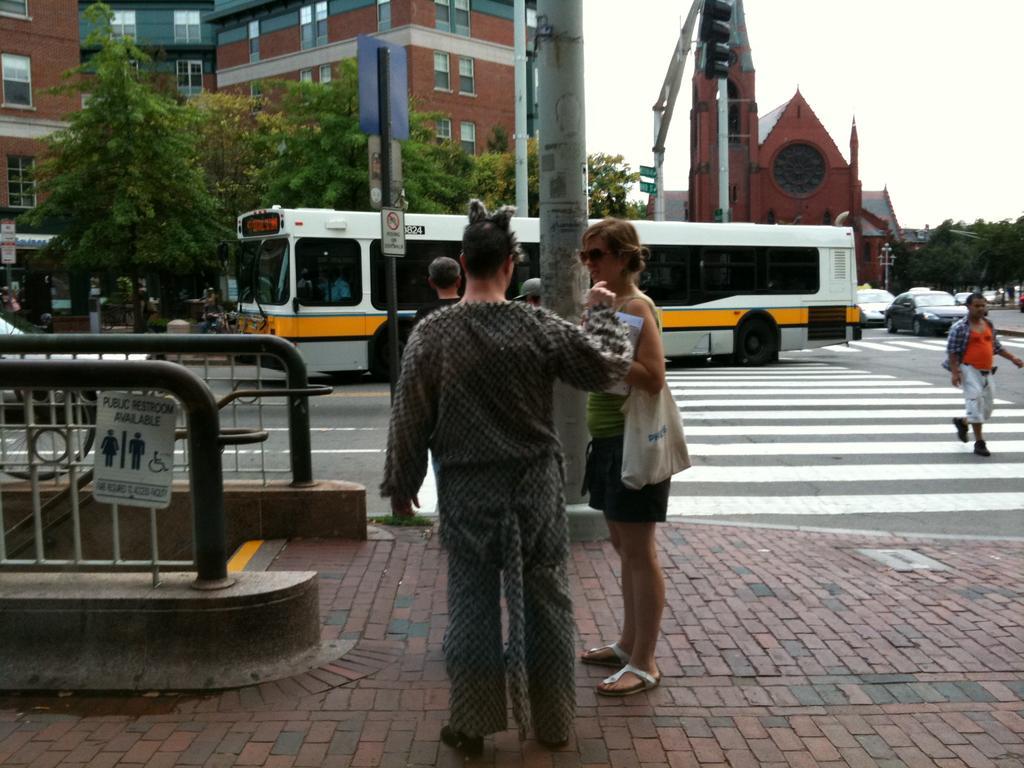Could you give a brief overview of what you see in this image? In this image, we can see some people standing on the path, we can see the road, there is a zebra crossing on the road, we can see a bus on the road, there are some cars on the right side of the image, we can see some buildings and there are some green trees, we can see the poles, at the top there is a sky. 